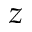Convert formula to latex. <formula><loc_0><loc_0><loc_500><loc_500>z</formula> 